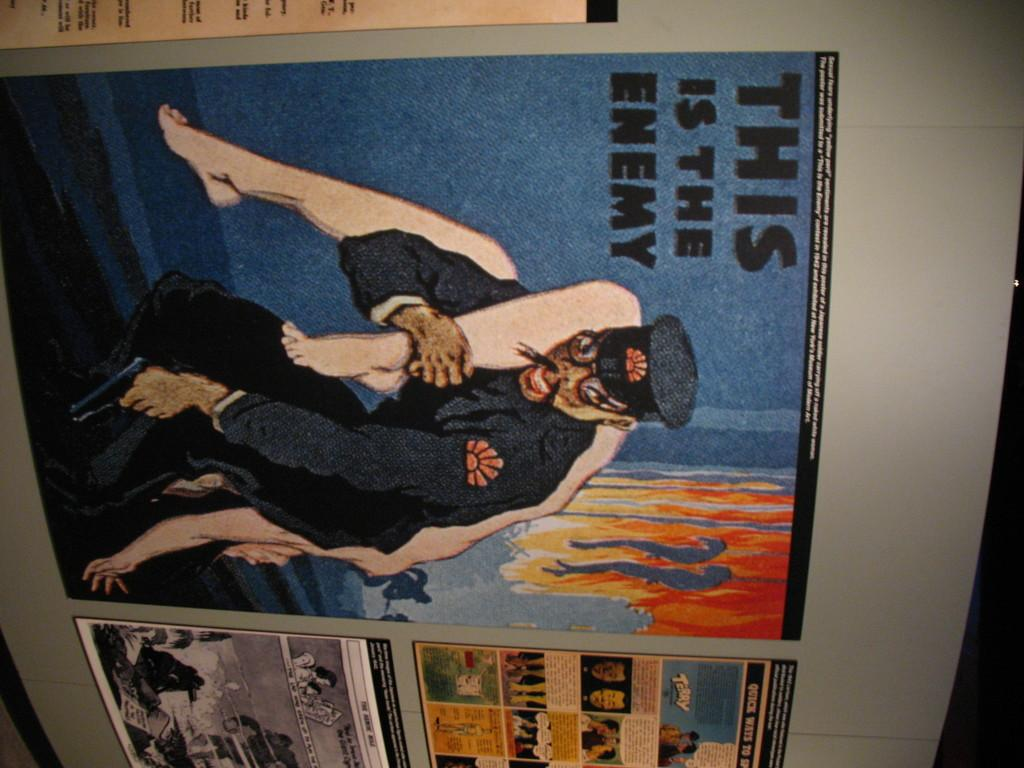<image>
Relay a brief, clear account of the picture shown. A piece of paper with the headline THIS IS THE ENEMY is attached to a wall. 